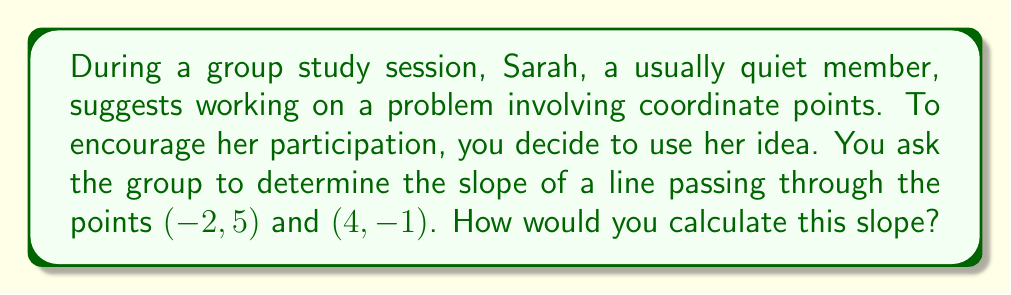Show me your answer to this math problem. Let's approach this step-by-step:

1) The slope formula for a line passing through two points $(x_1, y_1)$ and $(x_2, y_2)$ is:

   $$m = \frac{y_2 - y_1}{x_2 - x_1}$$

2) In this case, we have:
   $(x_1, y_1) = (-2, 5)$
   $(x_2, y_2) = (4, -1)$

3) Let's substitute these values into the formula:

   $$m = \frac{-1 - 5}{4 - (-2)}$$

4) Simplify the numerator and denominator:

   $$m = \frac{-6}{6}$$

5) Divide:

   $$m = -1$$

Therefore, the slope of the line passing through the points $(-2, 5)$ and $(4, -1)$ is $-1$.

[asy]
unitsize(1cm);
draw((-3,-2)--(5,2), arrow=Arrow(TeXHead));
draw((-3,-2)--(5,-2), arrow=Arrow(TeXHead));
dot((-2,5));
dot((4,-1));
label("(-2,5)", (-2,5), NE);
label("(4,-1)", (4,-1), SE);
label("x", (5,-2), E);
label("y", (-3,2), N);
[/asy]
Answer: $m = -1$ 